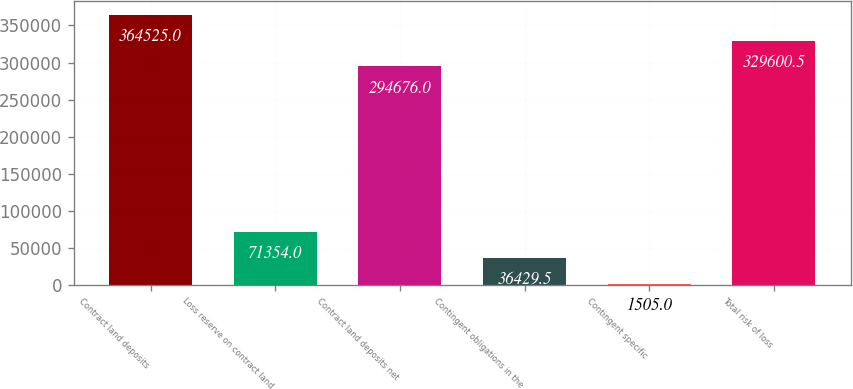Convert chart. <chart><loc_0><loc_0><loc_500><loc_500><bar_chart><fcel>Contract land deposits<fcel>Loss reserve on contract land<fcel>Contract land deposits net<fcel>Contingent obligations in the<fcel>Contingent specific<fcel>Total risk of loss<nl><fcel>364525<fcel>71354<fcel>294676<fcel>36429.5<fcel>1505<fcel>329600<nl></chart> 